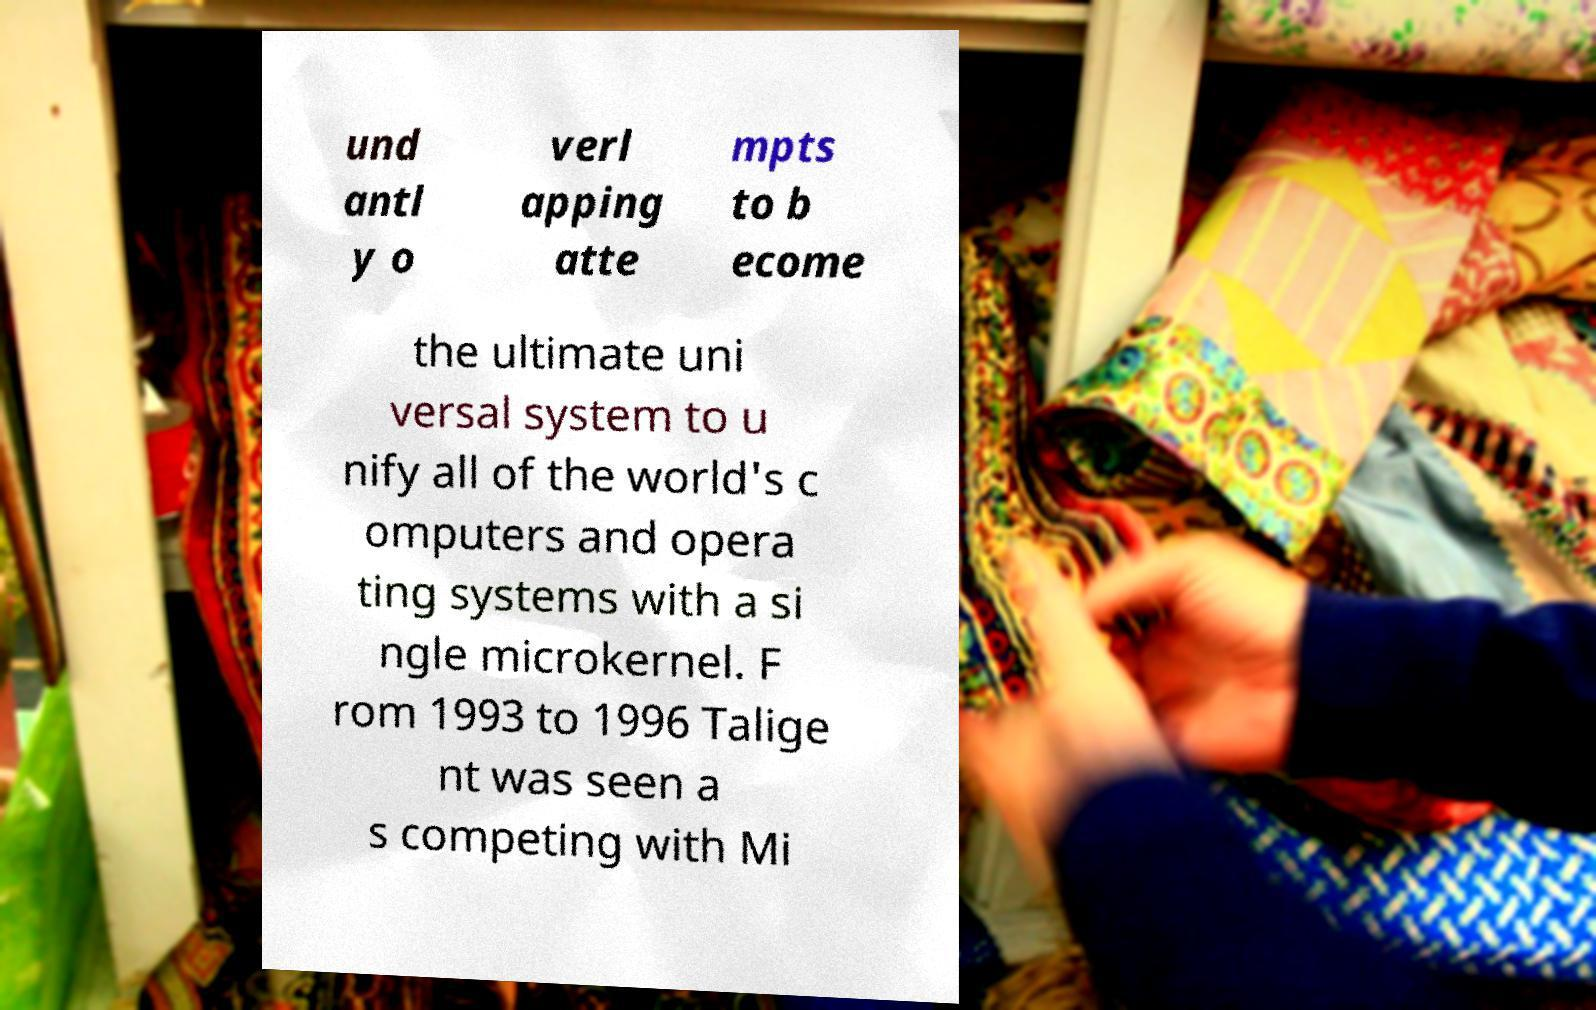What messages or text are displayed in this image? I need them in a readable, typed format. und antl y o verl apping atte mpts to b ecome the ultimate uni versal system to u nify all of the world's c omputers and opera ting systems with a si ngle microkernel. F rom 1993 to 1996 Talige nt was seen a s competing with Mi 